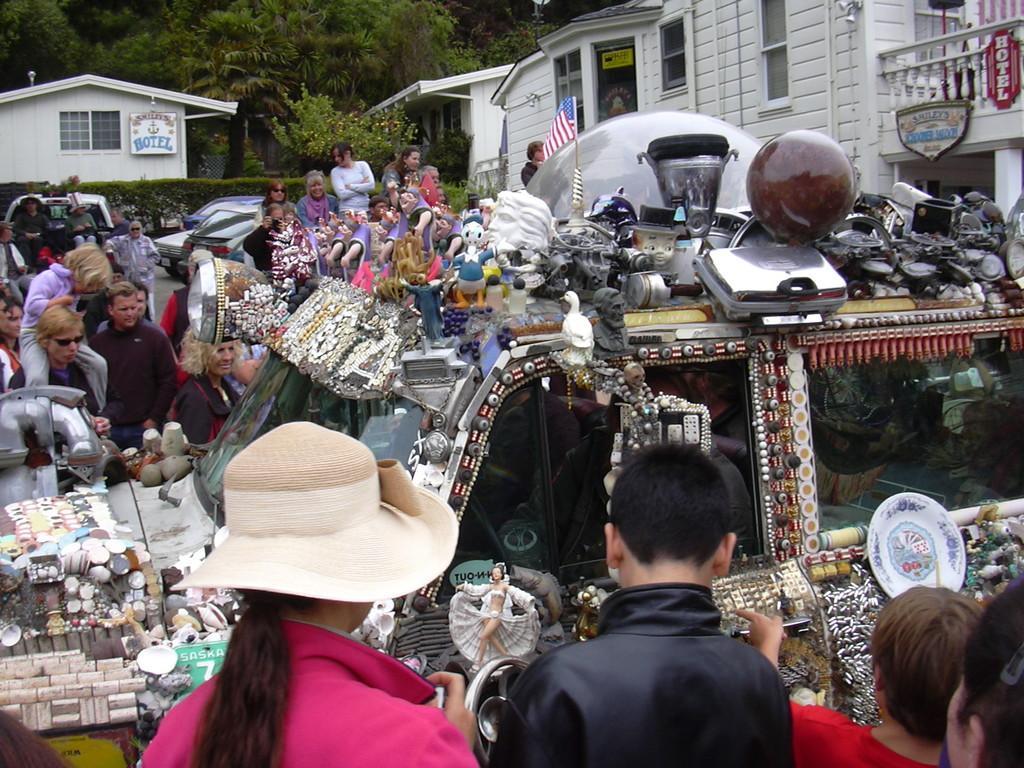Could you give a brief overview of what you see in this image? In this image we can see a car on the ground which is decorated with some devices and objects. We can also see a group of people around it, some cars on the road, plants, some buildings, the flag, the sign boards with some text on them and a group of trees. 